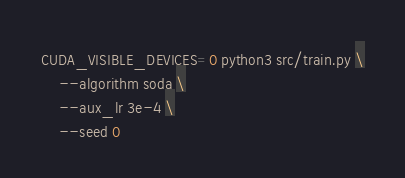<code> <loc_0><loc_0><loc_500><loc_500><_Bash_>CUDA_VISIBLE_DEVICES=0 python3 src/train.py \
	--algorithm soda \
	--aux_lr 3e-4 \
	--seed 0</code> 